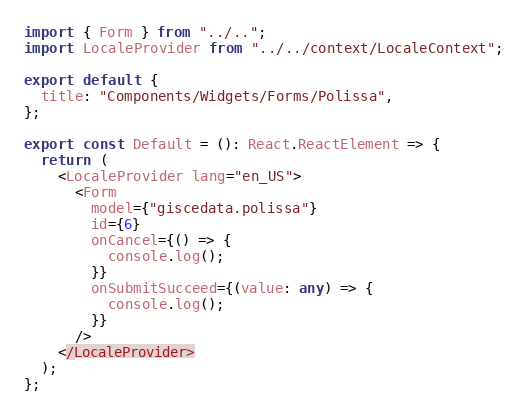<code> <loc_0><loc_0><loc_500><loc_500><_TypeScript_>import { Form } from "../..";
import LocaleProvider from "../../context/LocaleContext";

export default {
  title: "Components/Widgets/Forms/Polissa",
};

export const Default = (): React.ReactElement => {
  return (
    <LocaleProvider lang="en_US">
      <Form
        model={"giscedata.polissa"}
        id={6}
        onCancel={() => {
          console.log();
        }}
        onSubmitSucceed={(value: any) => {
          console.log();
        }}
      />
    </LocaleProvider>
  );
};
</code> 